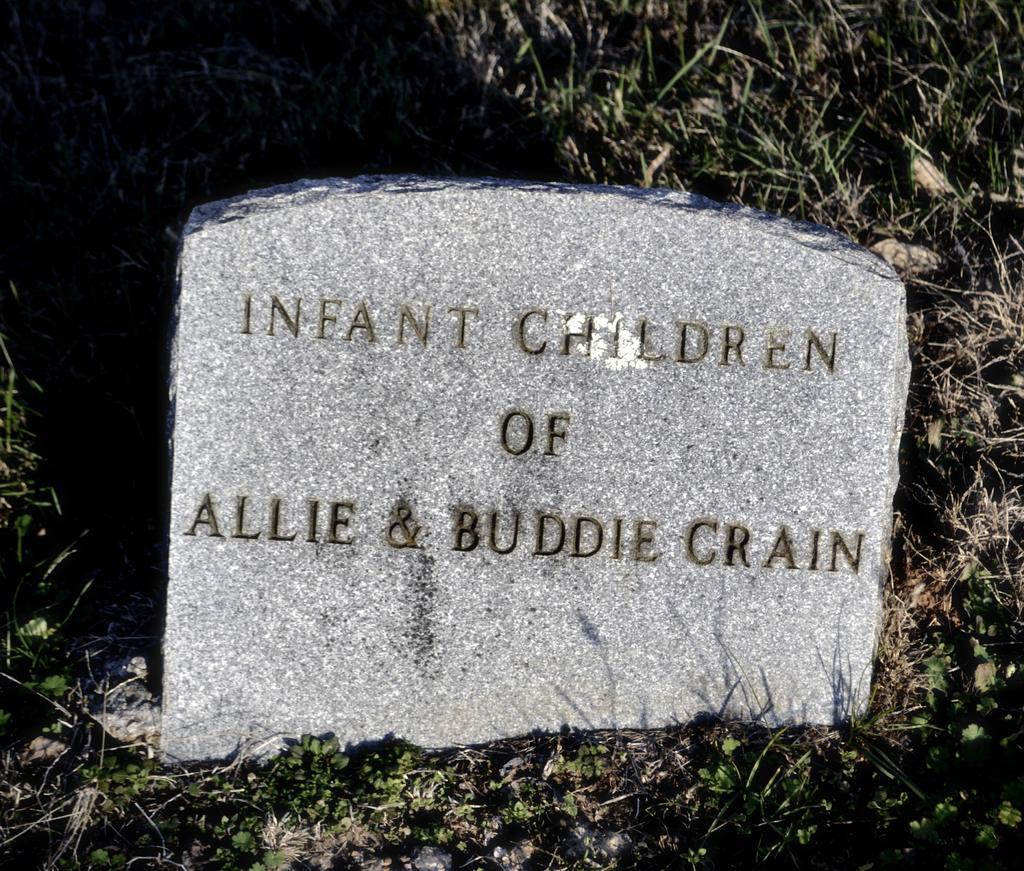Can you describe this image briefly? In the center of the image there is a stone with some text on it. At the bottom of the image there is grass. 